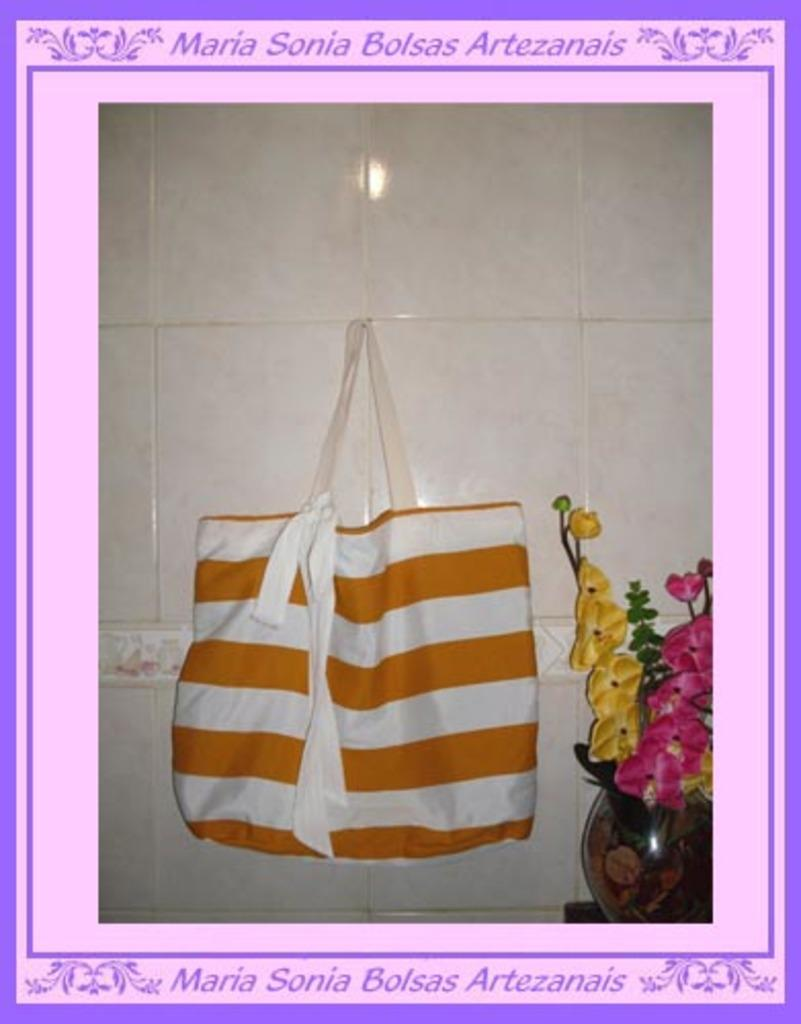What is hanging on the wall in the image? There is a bag hanging on the wall in the image. What other object can be seen in the image? There is a flower vase in the image. How was the image manipulated before being presented? The image has been edited on a computer. Where is the secretary sitting in the image? There is no secretary present in the image. How many trees are visible in the image? There are no trees visible in the image. 